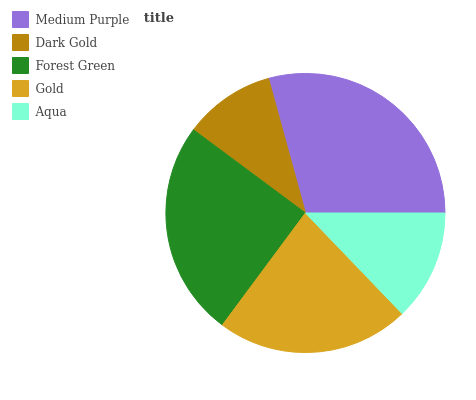Is Dark Gold the minimum?
Answer yes or no. Yes. Is Medium Purple the maximum?
Answer yes or no. Yes. Is Forest Green the minimum?
Answer yes or no. No. Is Forest Green the maximum?
Answer yes or no. No. Is Forest Green greater than Dark Gold?
Answer yes or no. Yes. Is Dark Gold less than Forest Green?
Answer yes or no. Yes. Is Dark Gold greater than Forest Green?
Answer yes or no. No. Is Forest Green less than Dark Gold?
Answer yes or no. No. Is Gold the high median?
Answer yes or no. Yes. Is Gold the low median?
Answer yes or no. Yes. Is Dark Gold the high median?
Answer yes or no. No. Is Dark Gold the low median?
Answer yes or no. No. 